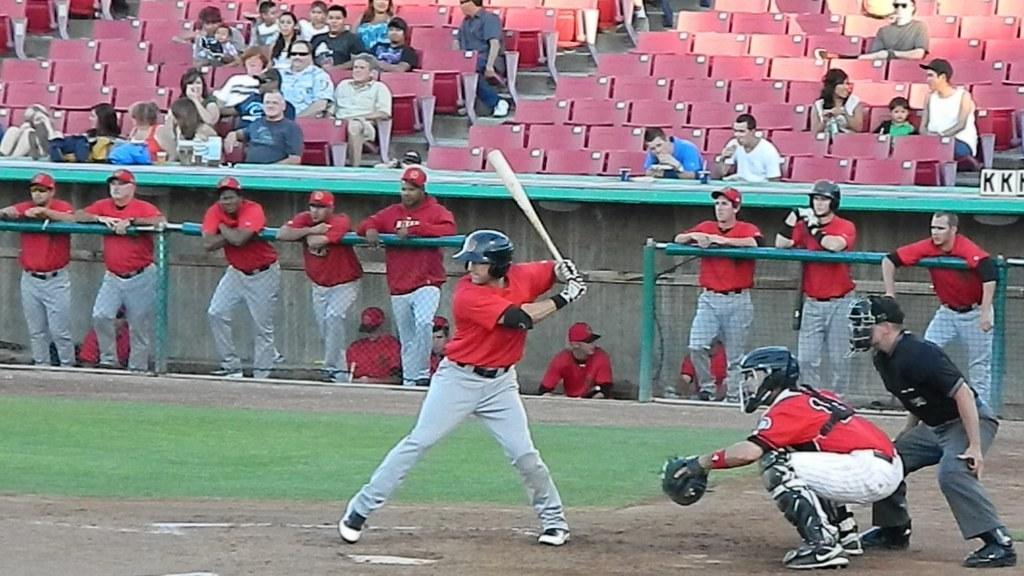<image>
Summarize the visual content of the image. A man at bat with the Letter KK behind with umpire. 